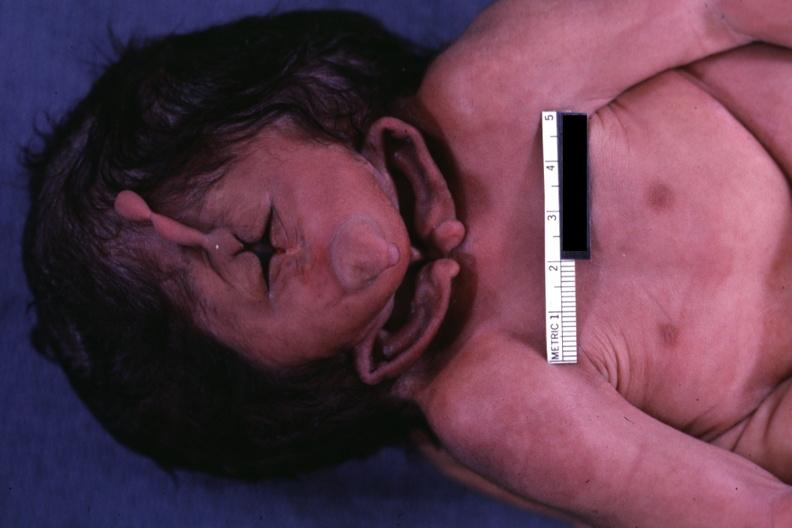how many side does this image show close-up view of of head?
Answer the question using a single word or phrase. One 